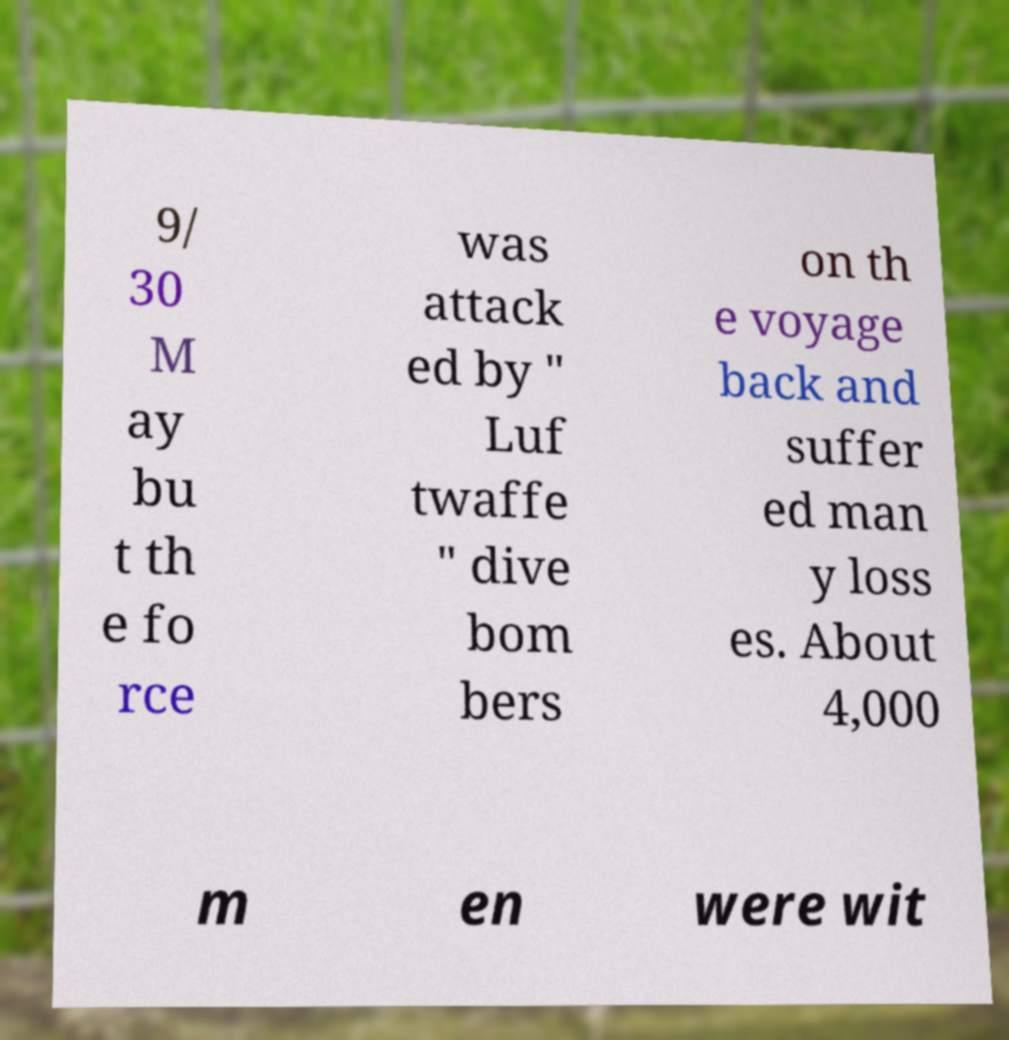I need the written content from this picture converted into text. Can you do that? 9/ 30 M ay bu t th e fo rce was attack ed by " Luf twaffe " dive bom bers on th e voyage back and suffer ed man y loss es. About 4,000 m en were wit 